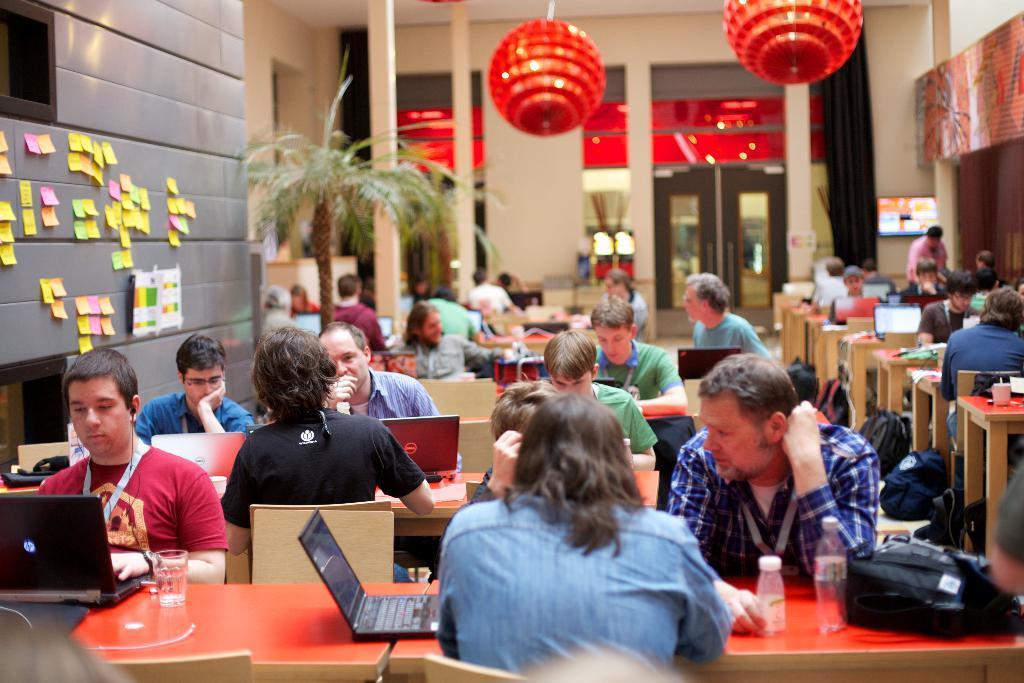Please provide a concise description of this image. In this image I can see group of people sitting and I can also see few laptops, bottles, bags, glasses on the table. I can also see few papers attached to the wall, plants in green color. I can also see few lights and the wall is in cream color. 